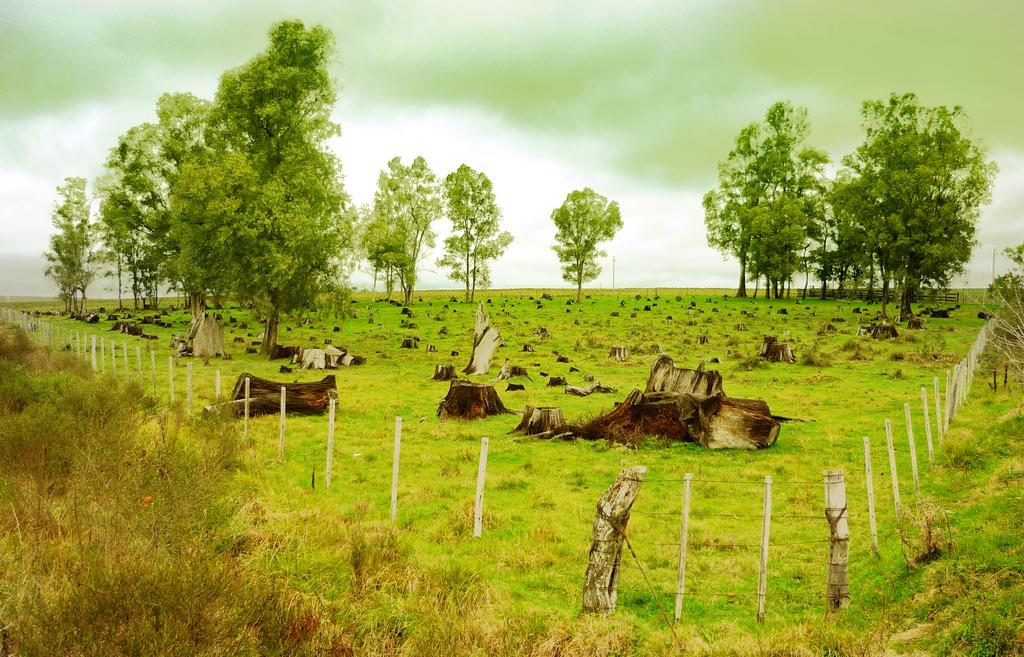What types of objects can be seen in the image? There are objects in the image, but their specific nature is not mentioned in the facts. What color are the trees in the image? The trees in the image are green. How is the ground depicted in the image? The ground is covered in greenery. What is the condition of the sky in the image? The facts do not mention any user or person in the image. What is the condition of the sky in the image? The sky is cloudy in the image. What type of jelly is being used to treat the disease in the image? There is no mention of jelly, disease, or any medical treatment in the image. 